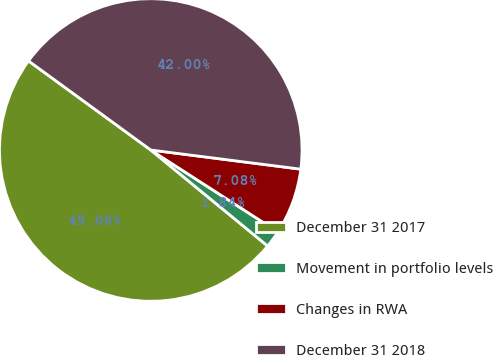<chart> <loc_0><loc_0><loc_500><loc_500><pie_chart><fcel>December 31 2017<fcel>Movement in portfolio levels<fcel>Changes in RWA<fcel>December 31 2018<nl><fcel>49.08%<fcel>1.84%<fcel>7.08%<fcel>42.0%<nl></chart> 